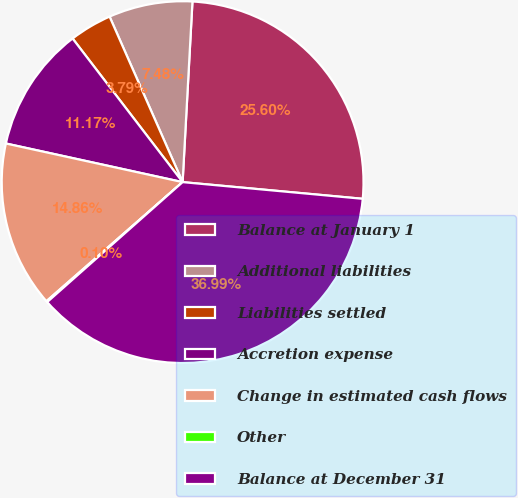Convert chart. <chart><loc_0><loc_0><loc_500><loc_500><pie_chart><fcel>Balance at January 1<fcel>Additional liabilities<fcel>Liabilities settled<fcel>Accretion expense<fcel>Change in estimated cash flows<fcel>Other<fcel>Balance at December 31<nl><fcel>25.6%<fcel>7.48%<fcel>3.79%<fcel>11.17%<fcel>14.86%<fcel>0.1%<fcel>36.99%<nl></chart> 